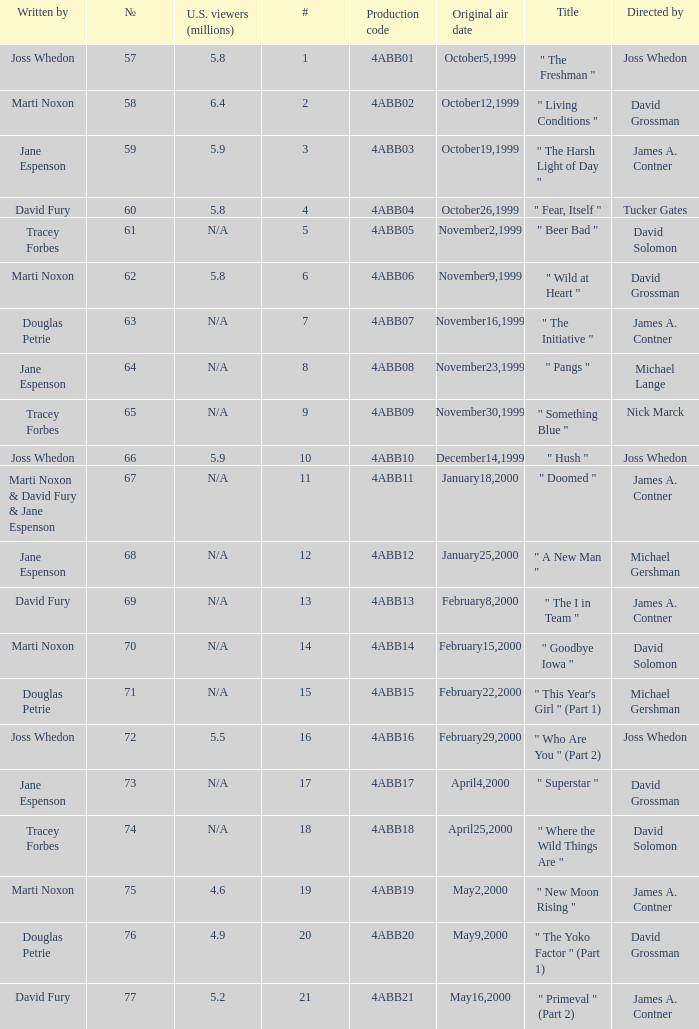What is the production code for the episode with 5.5 million u.s. viewers? 4ABB16. 